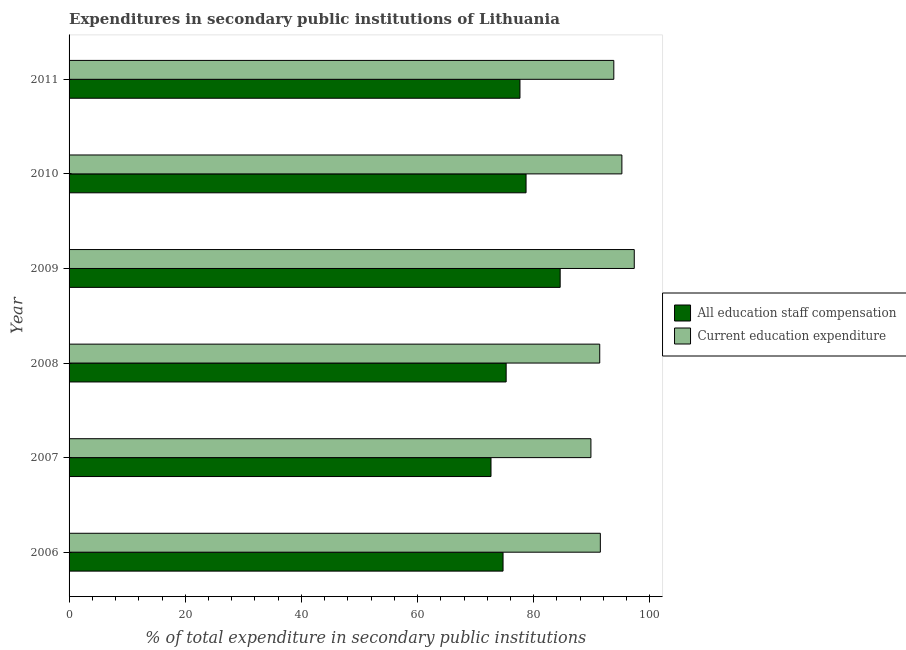How many groups of bars are there?
Provide a short and direct response. 6. How many bars are there on the 1st tick from the top?
Offer a terse response. 2. How many bars are there on the 1st tick from the bottom?
Your response must be concise. 2. In how many cases, is the number of bars for a given year not equal to the number of legend labels?
Give a very brief answer. 0. What is the expenditure in staff compensation in 2006?
Give a very brief answer. 74.71. Across all years, what is the maximum expenditure in staff compensation?
Provide a short and direct response. 84.55. Across all years, what is the minimum expenditure in staff compensation?
Keep it short and to the point. 72.64. In which year was the expenditure in staff compensation maximum?
Make the answer very short. 2009. In which year was the expenditure in staff compensation minimum?
Your answer should be very brief. 2007. What is the total expenditure in education in the graph?
Your answer should be very brief. 558.93. What is the difference between the expenditure in education in 2008 and that in 2010?
Your answer should be compact. -3.81. What is the difference between the expenditure in staff compensation in 2009 and the expenditure in education in 2007?
Your response must be concise. -5.29. What is the average expenditure in education per year?
Provide a short and direct response. 93.16. In the year 2010, what is the difference between the expenditure in staff compensation and expenditure in education?
Give a very brief answer. -16.5. What is the ratio of the expenditure in education in 2009 to that in 2011?
Ensure brevity in your answer.  1.04. Is the expenditure in education in 2007 less than that in 2010?
Ensure brevity in your answer.  Yes. What is the difference between the highest and the second highest expenditure in education?
Offer a terse response. 2.13. What is the difference between the highest and the lowest expenditure in education?
Provide a short and direct response. 7.46. In how many years, is the expenditure in staff compensation greater than the average expenditure in staff compensation taken over all years?
Make the answer very short. 3. What does the 2nd bar from the top in 2006 represents?
Your response must be concise. All education staff compensation. What does the 2nd bar from the bottom in 2009 represents?
Provide a succinct answer. Current education expenditure. How many bars are there?
Your answer should be compact. 12. How many years are there in the graph?
Provide a short and direct response. 6. Does the graph contain any zero values?
Give a very brief answer. No. Does the graph contain grids?
Make the answer very short. No. What is the title of the graph?
Give a very brief answer. Expenditures in secondary public institutions of Lithuania. What is the label or title of the X-axis?
Offer a terse response. % of total expenditure in secondary public institutions. What is the label or title of the Y-axis?
Provide a short and direct response. Year. What is the % of total expenditure in secondary public institutions in All education staff compensation in 2006?
Provide a succinct answer. 74.71. What is the % of total expenditure in secondary public institutions of Current education expenditure in 2006?
Your answer should be compact. 91.47. What is the % of total expenditure in secondary public institutions of All education staff compensation in 2007?
Make the answer very short. 72.64. What is the % of total expenditure in secondary public institutions in Current education expenditure in 2007?
Keep it short and to the point. 89.84. What is the % of total expenditure in secondary public institutions in All education staff compensation in 2008?
Offer a terse response. 75.25. What is the % of total expenditure in secondary public institutions of Current education expenditure in 2008?
Ensure brevity in your answer.  91.36. What is the % of total expenditure in secondary public institutions in All education staff compensation in 2009?
Your response must be concise. 84.55. What is the % of total expenditure in secondary public institutions of Current education expenditure in 2009?
Give a very brief answer. 97.3. What is the % of total expenditure in secondary public institutions of All education staff compensation in 2010?
Give a very brief answer. 78.68. What is the % of total expenditure in secondary public institutions in Current education expenditure in 2010?
Your response must be concise. 95.18. What is the % of total expenditure in secondary public institutions in All education staff compensation in 2011?
Keep it short and to the point. 77.63. What is the % of total expenditure in secondary public institutions of Current education expenditure in 2011?
Offer a terse response. 93.78. Across all years, what is the maximum % of total expenditure in secondary public institutions of All education staff compensation?
Your answer should be very brief. 84.55. Across all years, what is the maximum % of total expenditure in secondary public institutions in Current education expenditure?
Your response must be concise. 97.3. Across all years, what is the minimum % of total expenditure in secondary public institutions in All education staff compensation?
Provide a short and direct response. 72.64. Across all years, what is the minimum % of total expenditure in secondary public institutions of Current education expenditure?
Ensure brevity in your answer.  89.84. What is the total % of total expenditure in secondary public institutions in All education staff compensation in the graph?
Your response must be concise. 463.46. What is the total % of total expenditure in secondary public institutions of Current education expenditure in the graph?
Offer a very short reply. 558.93. What is the difference between the % of total expenditure in secondary public institutions in All education staff compensation in 2006 and that in 2007?
Ensure brevity in your answer.  2.07. What is the difference between the % of total expenditure in secondary public institutions in Current education expenditure in 2006 and that in 2007?
Your answer should be very brief. 1.62. What is the difference between the % of total expenditure in secondary public institutions of All education staff compensation in 2006 and that in 2008?
Your answer should be very brief. -0.54. What is the difference between the % of total expenditure in secondary public institutions of Current education expenditure in 2006 and that in 2008?
Give a very brief answer. 0.11. What is the difference between the % of total expenditure in secondary public institutions of All education staff compensation in 2006 and that in 2009?
Offer a terse response. -9.84. What is the difference between the % of total expenditure in secondary public institutions of Current education expenditure in 2006 and that in 2009?
Keep it short and to the point. -5.84. What is the difference between the % of total expenditure in secondary public institutions of All education staff compensation in 2006 and that in 2010?
Your response must be concise. -3.96. What is the difference between the % of total expenditure in secondary public institutions in Current education expenditure in 2006 and that in 2010?
Provide a short and direct response. -3.71. What is the difference between the % of total expenditure in secondary public institutions in All education staff compensation in 2006 and that in 2011?
Make the answer very short. -2.91. What is the difference between the % of total expenditure in secondary public institutions of Current education expenditure in 2006 and that in 2011?
Your answer should be very brief. -2.32. What is the difference between the % of total expenditure in secondary public institutions of All education staff compensation in 2007 and that in 2008?
Provide a succinct answer. -2.61. What is the difference between the % of total expenditure in secondary public institutions of Current education expenditure in 2007 and that in 2008?
Offer a very short reply. -1.52. What is the difference between the % of total expenditure in secondary public institutions in All education staff compensation in 2007 and that in 2009?
Provide a short and direct response. -11.91. What is the difference between the % of total expenditure in secondary public institutions in Current education expenditure in 2007 and that in 2009?
Your answer should be compact. -7.46. What is the difference between the % of total expenditure in secondary public institutions of All education staff compensation in 2007 and that in 2010?
Make the answer very short. -6.04. What is the difference between the % of total expenditure in secondary public institutions in Current education expenditure in 2007 and that in 2010?
Offer a very short reply. -5.33. What is the difference between the % of total expenditure in secondary public institutions in All education staff compensation in 2007 and that in 2011?
Keep it short and to the point. -4.99. What is the difference between the % of total expenditure in secondary public institutions in Current education expenditure in 2007 and that in 2011?
Provide a succinct answer. -3.94. What is the difference between the % of total expenditure in secondary public institutions of All education staff compensation in 2008 and that in 2009?
Give a very brief answer. -9.3. What is the difference between the % of total expenditure in secondary public institutions in Current education expenditure in 2008 and that in 2009?
Keep it short and to the point. -5.94. What is the difference between the % of total expenditure in secondary public institutions of All education staff compensation in 2008 and that in 2010?
Offer a very short reply. -3.43. What is the difference between the % of total expenditure in secondary public institutions of Current education expenditure in 2008 and that in 2010?
Your answer should be compact. -3.82. What is the difference between the % of total expenditure in secondary public institutions in All education staff compensation in 2008 and that in 2011?
Your response must be concise. -2.38. What is the difference between the % of total expenditure in secondary public institutions in Current education expenditure in 2008 and that in 2011?
Provide a short and direct response. -2.42. What is the difference between the % of total expenditure in secondary public institutions in All education staff compensation in 2009 and that in 2010?
Your answer should be compact. 5.87. What is the difference between the % of total expenditure in secondary public institutions of Current education expenditure in 2009 and that in 2010?
Keep it short and to the point. 2.13. What is the difference between the % of total expenditure in secondary public institutions in All education staff compensation in 2009 and that in 2011?
Provide a short and direct response. 6.92. What is the difference between the % of total expenditure in secondary public institutions in Current education expenditure in 2009 and that in 2011?
Your answer should be compact. 3.52. What is the difference between the % of total expenditure in secondary public institutions in All education staff compensation in 2010 and that in 2011?
Ensure brevity in your answer.  1.05. What is the difference between the % of total expenditure in secondary public institutions of Current education expenditure in 2010 and that in 2011?
Keep it short and to the point. 1.39. What is the difference between the % of total expenditure in secondary public institutions in All education staff compensation in 2006 and the % of total expenditure in secondary public institutions in Current education expenditure in 2007?
Your answer should be very brief. -15.13. What is the difference between the % of total expenditure in secondary public institutions of All education staff compensation in 2006 and the % of total expenditure in secondary public institutions of Current education expenditure in 2008?
Your response must be concise. -16.65. What is the difference between the % of total expenditure in secondary public institutions in All education staff compensation in 2006 and the % of total expenditure in secondary public institutions in Current education expenditure in 2009?
Your answer should be compact. -22.59. What is the difference between the % of total expenditure in secondary public institutions in All education staff compensation in 2006 and the % of total expenditure in secondary public institutions in Current education expenditure in 2010?
Provide a succinct answer. -20.46. What is the difference between the % of total expenditure in secondary public institutions in All education staff compensation in 2006 and the % of total expenditure in secondary public institutions in Current education expenditure in 2011?
Give a very brief answer. -19.07. What is the difference between the % of total expenditure in secondary public institutions of All education staff compensation in 2007 and the % of total expenditure in secondary public institutions of Current education expenditure in 2008?
Give a very brief answer. -18.72. What is the difference between the % of total expenditure in secondary public institutions of All education staff compensation in 2007 and the % of total expenditure in secondary public institutions of Current education expenditure in 2009?
Ensure brevity in your answer.  -24.66. What is the difference between the % of total expenditure in secondary public institutions in All education staff compensation in 2007 and the % of total expenditure in secondary public institutions in Current education expenditure in 2010?
Your response must be concise. -22.54. What is the difference between the % of total expenditure in secondary public institutions of All education staff compensation in 2007 and the % of total expenditure in secondary public institutions of Current education expenditure in 2011?
Make the answer very short. -21.14. What is the difference between the % of total expenditure in secondary public institutions in All education staff compensation in 2008 and the % of total expenditure in secondary public institutions in Current education expenditure in 2009?
Provide a short and direct response. -22.05. What is the difference between the % of total expenditure in secondary public institutions in All education staff compensation in 2008 and the % of total expenditure in secondary public institutions in Current education expenditure in 2010?
Offer a very short reply. -19.93. What is the difference between the % of total expenditure in secondary public institutions of All education staff compensation in 2008 and the % of total expenditure in secondary public institutions of Current education expenditure in 2011?
Offer a very short reply. -18.53. What is the difference between the % of total expenditure in secondary public institutions of All education staff compensation in 2009 and the % of total expenditure in secondary public institutions of Current education expenditure in 2010?
Ensure brevity in your answer.  -10.63. What is the difference between the % of total expenditure in secondary public institutions of All education staff compensation in 2009 and the % of total expenditure in secondary public institutions of Current education expenditure in 2011?
Make the answer very short. -9.23. What is the difference between the % of total expenditure in secondary public institutions in All education staff compensation in 2010 and the % of total expenditure in secondary public institutions in Current education expenditure in 2011?
Ensure brevity in your answer.  -15.11. What is the average % of total expenditure in secondary public institutions in All education staff compensation per year?
Offer a terse response. 77.24. What is the average % of total expenditure in secondary public institutions in Current education expenditure per year?
Ensure brevity in your answer.  93.16. In the year 2006, what is the difference between the % of total expenditure in secondary public institutions in All education staff compensation and % of total expenditure in secondary public institutions in Current education expenditure?
Your answer should be very brief. -16.75. In the year 2007, what is the difference between the % of total expenditure in secondary public institutions of All education staff compensation and % of total expenditure in secondary public institutions of Current education expenditure?
Keep it short and to the point. -17.2. In the year 2008, what is the difference between the % of total expenditure in secondary public institutions in All education staff compensation and % of total expenditure in secondary public institutions in Current education expenditure?
Provide a short and direct response. -16.11. In the year 2009, what is the difference between the % of total expenditure in secondary public institutions of All education staff compensation and % of total expenditure in secondary public institutions of Current education expenditure?
Offer a terse response. -12.75. In the year 2010, what is the difference between the % of total expenditure in secondary public institutions in All education staff compensation and % of total expenditure in secondary public institutions in Current education expenditure?
Ensure brevity in your answer.  -16.5. In the year 2011, what is the difference between the % of total expenditure in secondary public institutions in All education staff compensation and % of total expenditure in secondary public institutions in Current education expenditure?
Ensure brevity in your answer.  -16.16. What is the ratio of the % of total expenditure in secondary public institutions in All education staff compensation in 2006 to that in 2007?
Make the answer very short. 1.03. What is the ratio of the % of total expenditure in secondary public institutions of Current education expenditure in 2006 to that in 2007?
Offer a very short reply. 1.02. What is the ratio of the % of total expenditure in secondary public institutions of Current education expenditure in 2006 to that in 2008?
Your answer should be compact. 1. What is the ratio of the % of total expenditure in secondary public institutions of All education staff compensation in 2006 to that in 2009?
Offer a very short reply. 0.88. What is the ratio of the % of total expenditure in secondary public institutions of All education staff compensation in 2006 to that in 2010?
Offer a terse response. 0.95. What is the ratio of the % of total expenditure in secondary public institutions in All education staff compensation in 2006 to that in 2011?
Keep it short and to the point. 0.96. What is the ratio of the % of total expenditure in secondary public institutions of Current education expenditure in 2006 to that in 2011?
Your response must be concise. 0.98. What is the ratio of the % of total expenditure in secondary public institutions in All education staff compensation in 2007 to that in 2008?
Keep it short and to the point. 0.97. What is the ratio of the % of total expenditure in secondary public institutions of Current education expenditure in 2007 to that in 2008?
Your answer should be compact. 0.98. What is the ratio of the % of total expenditure in secondary public institutions in All education staff compensation in 2007 to that in 2009?
Ensure brevity in your answer.  0.86. What is the ratio of the % of total expenditure in secondary public institutions of Current education expenditure in 2007 to that in 2009?
Your answer should be very brief. 0.92. What is the ratio of the % of total expenditure in secondary public institutions of All education staff compensation in 2007 to that in 2010?
Offer a terse response. 0.92. What is the ratio of the % of total expenditure in secondary public institutions of Current education expenditure in 2007 to that in 2010?
Ensure brevity in your answer.  0.94. What is the ratio of the % of total expenditure in secondary public institutions in All education staff compensation in 2007 to that in 2011?
Provide a short and direct response. 0.94. What is the ratio of the % of total expenditure in secondary public institutions of Current education expenditure in 2007 to that in 2011?
Provide a short and direct response. 0.96. What is the ratio of the % of total expenditure in secondary public institutions in All education staff compensation in 2008 to that in 2009?
Your response must be concise. 0.89. What is the ratio of the % of total expenditure in secondary public institutions of Current education expenditure in 2008 to that in 2009?
Keep it short and to the point. 0.94. What is the ratio of the % of total expenditure in secondary public institutions of All education staff compensation in 2008 to that in 2010?
Give a very brief answer. 0.96. What is the ratio of the % of total expenditure in secondary public institutions in Current education expenditure in 2008 to that in 2010?
Give a very brief answer. 0.96. What is the ratio of the % of total expenditure in secondary public institutions in All education staff compensation in 2008 to that in 2011?
Offer a terse response. 0.97. What is the ratio of the % of total expenditure in secondary public institutions in Current education expenditure in 2008 to that in 2011?
Offer a very short reply. 0.97. What is the ratio of the % of total expenditure in secondary public institutions in All education staff compensation in 2009 to that in 2010?
Provide a short and direct response. 1.07. What is the ratio of the % of total expenditure in secondary public institutions in Current education expenditure in 2009 to that in 2010?
Your answer should be very brief. 1.02. What is the ratio of the % of total expenditure in secondary public institutions in All education staff compensation in 2009 to that in 2011?
Provide a succinct answer. 1.09. What is the ratio of the % of total expenditure in secondary public institutions in Current education expenditure in 2009 to that in 2011?
Provide a succinct answer. 1.04. What is the ratio of the % of total expenditure in secondary public institutions in All education staff compensation in 2010 to that in 2011?
Offer a very short reply. 1.01. What is the ratio of the % of total expenditure in secondary public institutions of Current education expenditure in 2010 to that in 2011?
Your response must be concise. 1.01. What is the difference between the highest and the second highest % of total expenditure in secondary public institutions of All education staff compensation?
Your answer should be compact. 5.87. What is the difference between the highest and the second highest % of total expenditure in secondary public institutions of Current education expenditure?
Offer a very short reply. 2.13. What is the difference between the highest and the lowest % of total expenditure in secondary public institutions in All education staff compensation?
Ensure brevity in your answer.  11.91. What is the difference between the highest and the lowest % of total expenditure in secondary public institutions in Current education expenditure?
Ensure brevity in your answer.  7.46. 